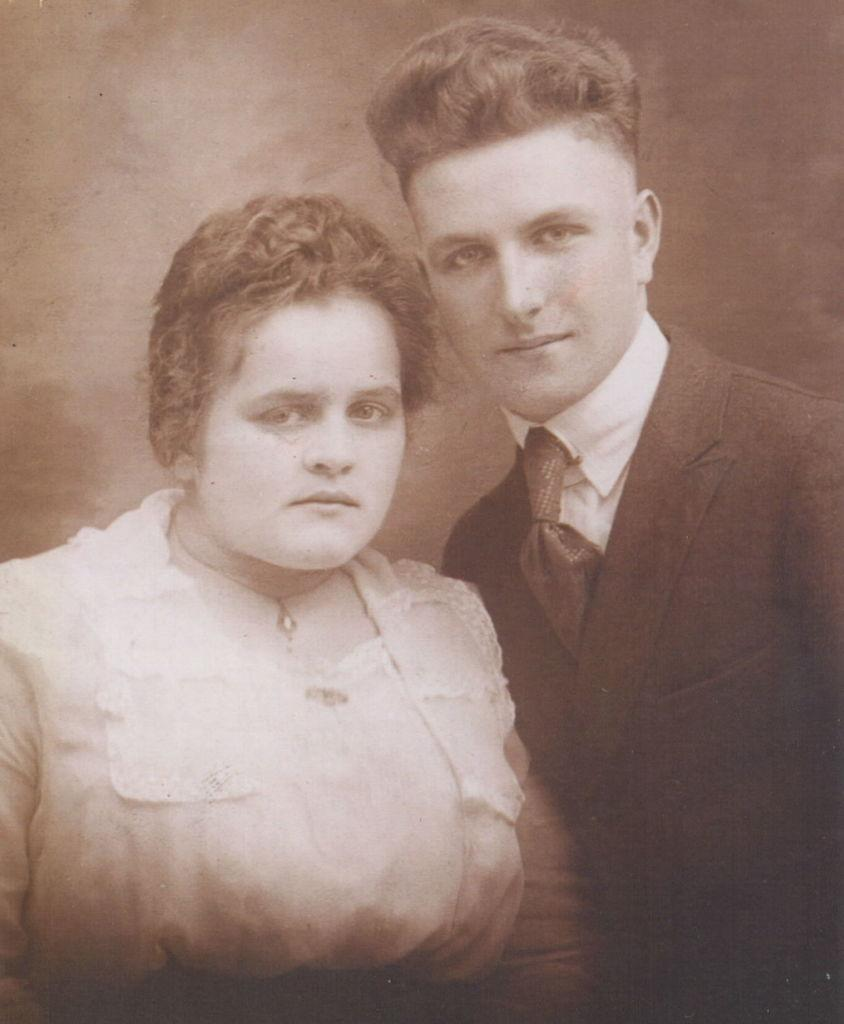What is the main subject of the image? The main subject of the image is a photo. What can be seen in the photo? The photo contains two persons. What is the history of the dad in the image? There is no dad present in the image, as the photo only contains two persons. 